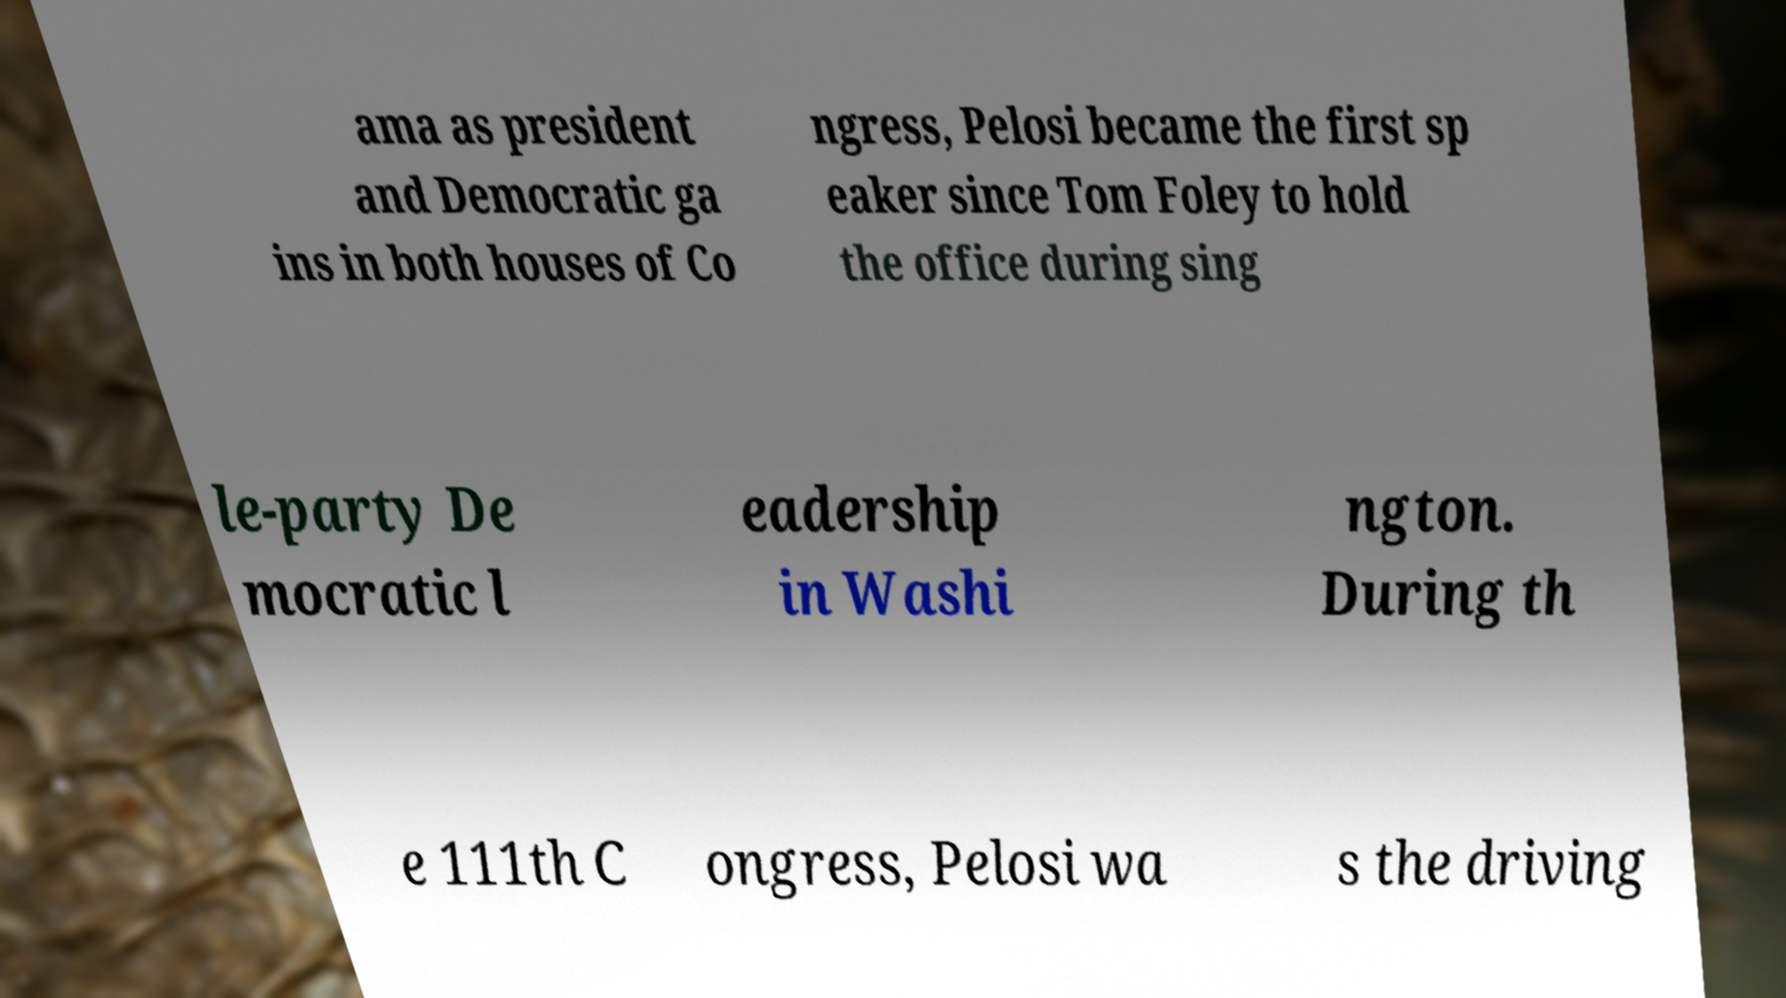Please identify and transcribe the text found in this image. ama as president and Democratic ga ins in both houses of Co ngress, Pelosi became the first sp eaker since Tom Foley to hold the office during sing le-party De mocratic l eadership in Washi ngton. During th e 111th C ongress, Pelosi wa s the driving 